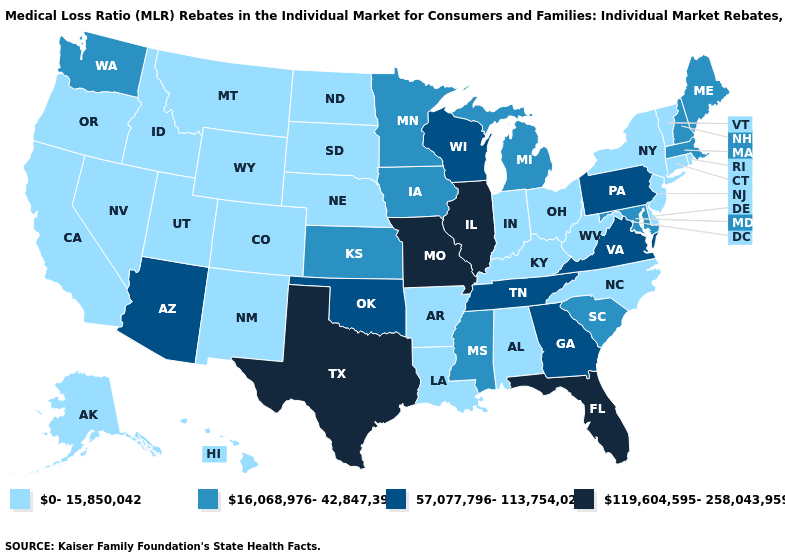Among the states that border Kansas , does Nebraska have the highest value?
Keep it brief. No. Name the states that have a value in the range 119,604,595-258,043,959?
Be succinct. Florida, Illinois, Missouri, Texas. Among the states that border Nebraska , which have the lowest value?
Give a very brief answer. Colorado, South Dakota, Wyoming. What is the lowest value in the USA?
Keep it brief. 0-15,850,042. Does Delaware have the same value as Maine?
Write a very short answer. No. What is the highest value in the USA?
Short answer required. 119,604,595-258,043,959. Which states have the lowest value in the USA?
Short answer required. Alabama, Alaska, Arkansas, California, Colorado, Connecticut, Delaware, Hawaii, Idaho, Indiana, Kentucky, Louisiana, Montana, Nebraska, Nevada, New Jersey, New Mexico, New York, North Carolina, North Dakota, Ohio, Oregon, Rhode Island, South Dakota, Utah, Vermont, West Virginia, Wyoming. What is the value of Nebraska?
Keep it brief. 0-15,850,042. What is the highest value in the USA?
Keep it brief. 119,604,595-258,043,959. Which states hav the highest value in the South?
Quick response, please. Florida, Texas. What is the lowest value in the USA?
Be succinct. 0-15,850,042. What is the lowest value in the USA?
Answer briefly. 0-15,850,042. Name the states that have a value in the range 119,604,595-258,043,959?
Concise answer only. Florida, Illinois, Missouri, Texas. Which states have the lowest value in the USA?
Concise answer only. Alabama, Alaska, Arkansas, California, Colorado, Connecticut, Delaware, Hawaii, Idaho, Indiana, Kentucky, Louisiana, Montana, Nebraska, Nevada, New Jersey, New Mexico, New York, North Carolina, North Dakota, Ohio, Oregon, Rhode Island, South Dakota, Utah, Vermont, West Virginia, Wyoming. Name the states that have a value in the range 57,077,796-113,754,024?
Quick response, please. Arizona, Georgia, Oklahoma, Pennsylvania, Tennessee, Virginia, Wisconsin. 